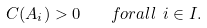Convert formula to latex. <formula><loc_0><loc_0><loc_500><loc_500>C ( A _ { i } ) > 0 \quad f o r a l l \ i \in I .</formula> 